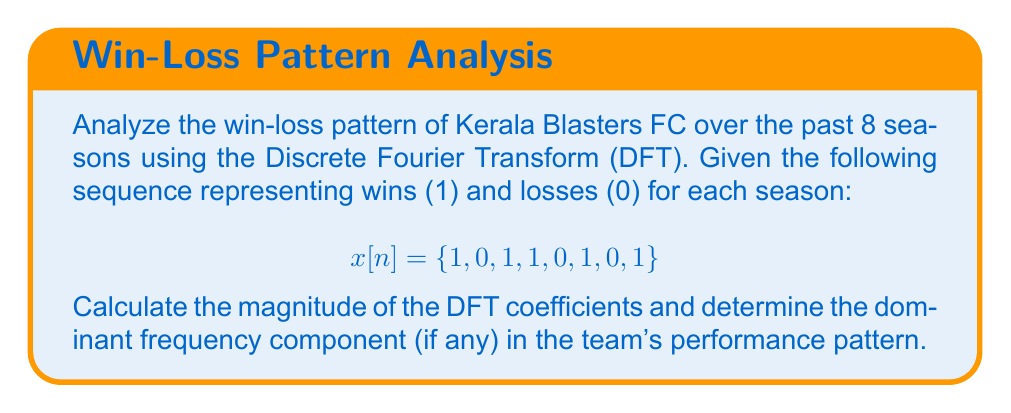Give your solution to this math problem. To analyze the periodicity of Kerala Blasters' win-loss records using the Discrete Fourier Transform (DFT), we'll follow these steps:

1) The DFT of a sequence x[n] of length N is given by:

   $$X[k] = \sum_{n=0}^{N-1} x[n] e^{-j2\pi kn/N}$$

   where k = 0, 1, ..., N-1

2) For our sequence x[n] = {1, 0, 1, 1, 0, 1, 0, 1} of length N = 8, we need to calculate X[k] for k = 0 to 7.

3) Let's calculate a few values:

   For k = 0:
   $$X[0] = 1 + 0 + 1 + 1 + 0 + 1 + 0 + 1 = 5$$

   For k = 1:
   $$X[1] = 1 + 0e^{-j\pi/4} + 1e^{-j\pi/2} + 1e^{-j3\pi/4} + 0e^{-j\pi} + 1e^{-j5\pi/4} + 0e^{-j3\pi/2} + 1e^{-j7\pi/4}$$

4) Calculating all values (which can be done efficiently using FFT algorithms):

   $$X[0] = 5$$
   $$X[1] = X[7]^* = 1 - j$$
   $$X[2] = X[6]^* = 1 + j$$
   $$X[3] = X[5]^* = -1 + j$$
   $$X[4] = 1$$

5) The magnitude of these coefficients:

   $$|X[0]| = 5$$
   $$|X[1]| = |X[7]| = \sqrt{2}$$
   $$|X[2]| = |X[6]| = \sqrt{2}$$
   $$|X[3]| = |X[5]| = \sqrt{2}$$
   $$|X[4]| = 1$$

6) The dominant frequency component is the one with the largest magnitude, which is X[0] with |X[0]| = 5. This represents the DC component (average) of the signal.

7) The next largest components are |X[1]|, |X[2]|, and |X[3]|, all equal to √2, suggesting no clear periodicity in the win-loss pattern.
Answer: No clear periodicity; dominant component is DC (X[0] = 5). 